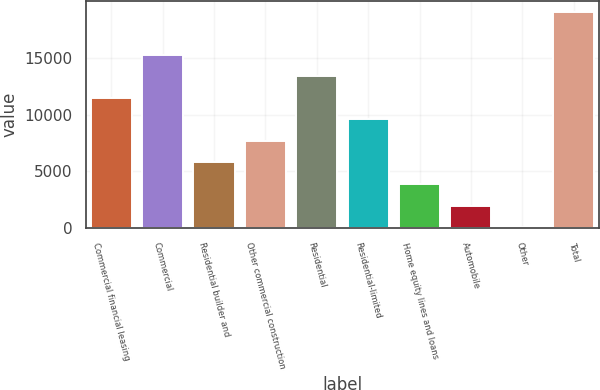<chart> <loc_0><loc_0><loc_500><loc_500><bar_chart><fcel>Commercial financial leasing<fcel>Commercial<fcel>Residential builder and<fcel>Other commercial construction<fcel>Residential<fcel>Residential-limited<fcel>Home equity lines and loans<fcel>Automobile<fcel>Other<fcel>Total<nl><fcel>11472.8<fcel>15259.4<fcel>5792.9<fcel>7686.2<fcel>13366.1<fcel>9579.5<fcel>3899.6<fcel>2006.3<fcel>113<fcel>19046<nl></chart> 